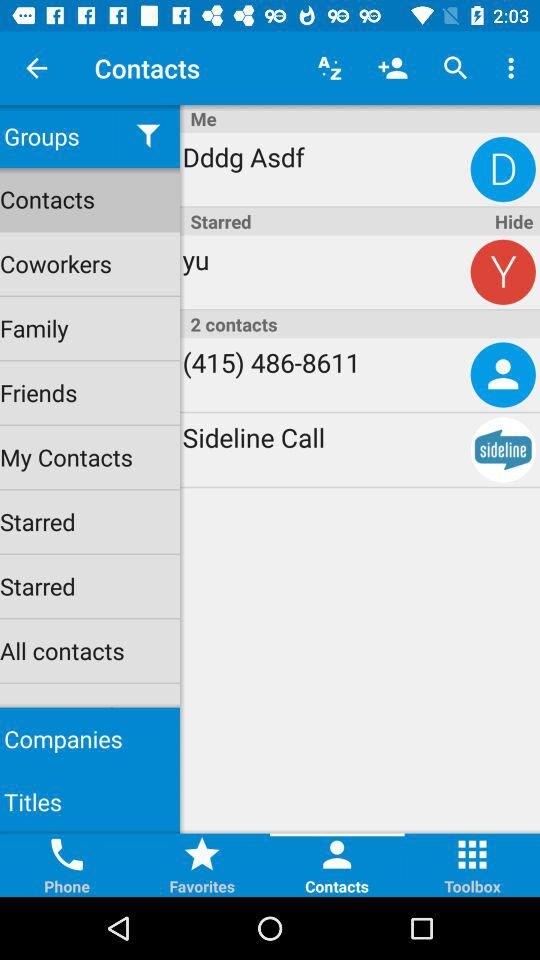What is the phone number? The phone number is (415) 486-8611. 